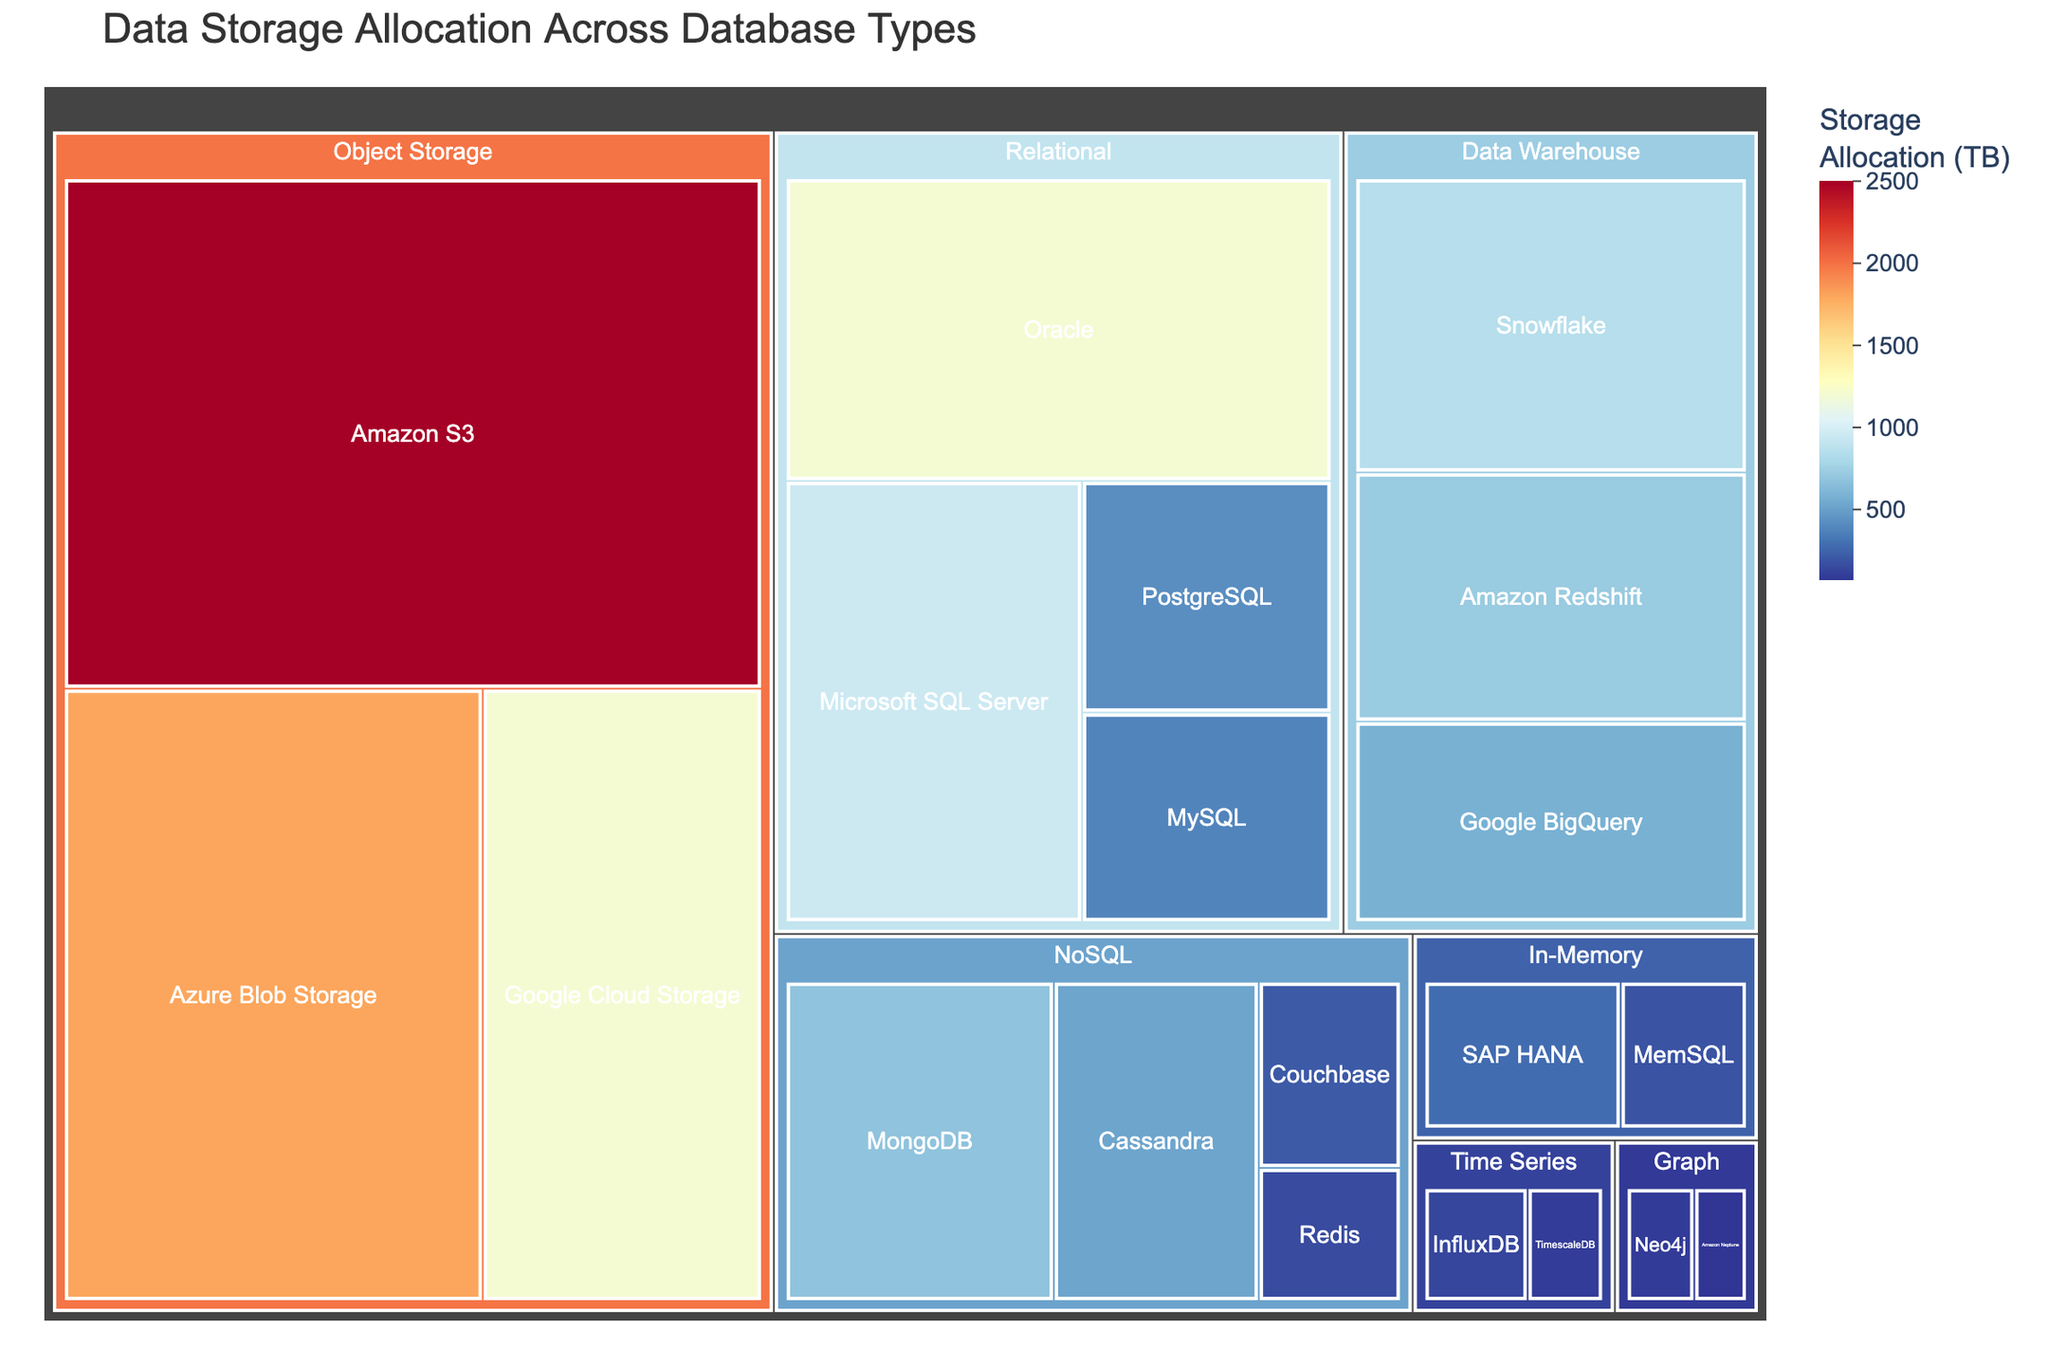What is the title of the figure? The title is usually prominently displayed at the top of the plot. By observing the figure, the title can be read directly.
Answer: Data Storage Allocation Across Database Types Which database type has the highest storage allocation? By observing the size of the tiles in the treemap, the type with the largest area represents the highest storage allocation.
Answer: Amazon S3 What is the total storage allocation for NoSQL databases? To find this, sum up the storage allocations for MongoDB, Cassandra, Couchbase, and Redis. 680 + 520 + 210 + 150 = 1560 TB
Answer: 1560 TB How does the storage allocation of PostgreSQL compare to MySQL? Comparing the sizes, PostgreSQL has a larger tile than MySQL, indicating higher storage allocation. PostgreSQL has 420 TB, and MySQL has 380 TB.
Answer: PostgreSQL is higher Which category has the smallest total storage allocation? By summing up the storage allocations within each category and comparing, the Graph category has the smallest total: 90 TB + 70 TB = 160 TB
Answer: Graph What is the combined storage allocation for object storage types (Amazon S3, Azure Blob Storage, Google Cloud Storage)? Sum up the given storage allocations: 2500 + 1800 + 1200 = 5500 TB
Answer: 5500 TB Which category contains the type with the smallest storage allocation, and what is that type? The smallest tile in the treemap represents the type with the smallest allocation, which belongs to the Graph category and is Amazon Neptune with 70 TB.
Answer: Graph, Amazon Neptune What is the average storage allocation across all relational database types? Sum the storage allocations of Oracle, Microsoft SQL Server, PostgreSQL, and MySQL, then divide by the number of types. (1200 + 950 + 420 + 380) / 4 = 2950 / 4 = 737.5 TB
Answer: 737.5 TB Compare the storage allocations of Snowflake and Amazon Redshift. Which one has more storage and by how much? Snowflake has 850 TB and Amazon Redshift has 720 TB. Subtract the two values to find the difference. 850 - 720 = 130 TB
Answer: Snowflake has 130 TB more What is the most predominant color in the treemap, and what does it signify? The largest tile, Amazon S3, is predominantly shown in a color representing high values on the color scale, likely indicating that this color signifies the highest storage allocations.
Answer: Color representing high storage allocation 